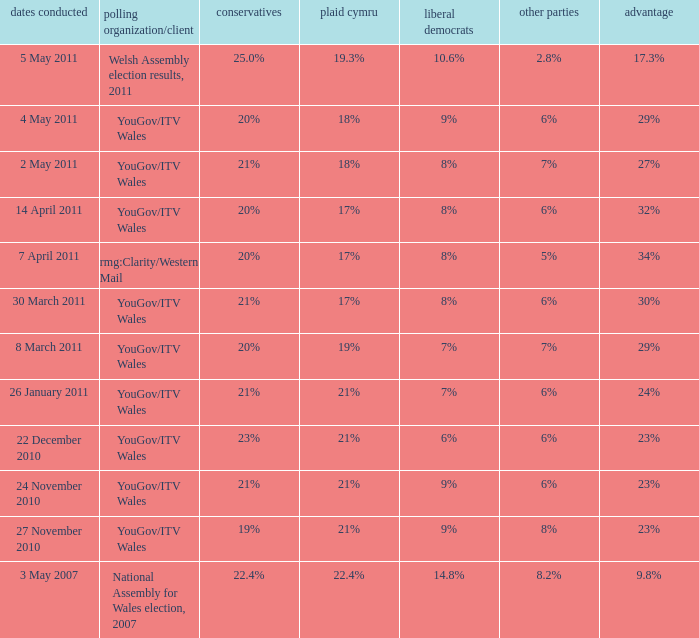I want the plaid cymru for Polling organisation/client of yougov/itv wales for 4 may 2011 18%. 